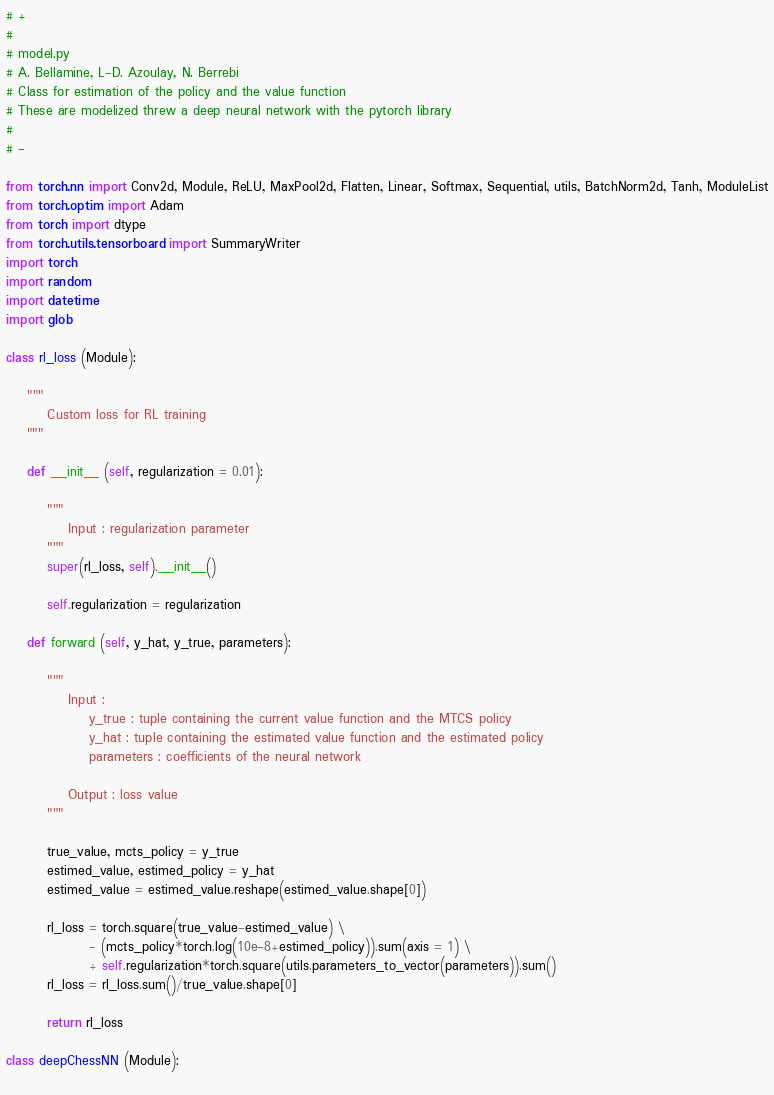<code> <loc_0><loc_0><loc_500><loc_500><_Python_># +
#
# model.py
# A. Bellamine, L-D. Azoulay, N. Berrebi
# Class for estimation of the policy and the value function
# These are modelized threw a deep neural network with the pytorch library
#
# -

from torch.nn import Conv2d, Module, ReLU, MaxPool2d, Flatten, Linear, Softmax, Sequential, utils, BatchNorm2d, Tanh, ModuleList
from torch.optim import Adam
from torch import dtype
from torch.utils.tensorboard import SummaryWriter
import torch
import random
import datetime
import glob

class rl_loss (Module):
    
    """
        Custom loss for RL training
    """
    
    def __init__ (self, regularization = 0.01):
        
        """
            Input : regularization parameter
        """
        super(rl_loss, self).__init__()
        
        self.regularization = regularization
        
    def forward (self, y_hat, y_true, parameters):
        
        """
            Input :
                y_true : tuple containing the current value function and the MTCS policy
                y_hat : tuple containing the estimated value function and the estimated policy
                parameters : coefficients of the neural network
                
            Output : loss value
        """
        
        true_value, mcts_policy = y_true
        estimed_value, estimed_policy = y_hat
        estimed_value = estimed_value.reshape(estimed_value.shape[0])

        rl_loss = torch.square(true_value-estimed_value) \
                - (mcts_policy*torch.log(10e-8+estimed_policy)).sum(axis = 1) \
                + self.regularization*torch.square(utils.parameters_to_vector(parameters)).sum()
        rl_loss = rl_loss.sum()/true_value.shape[0]
        
        return rl_loss
    
class deepChessNN (Module):
    </code> 